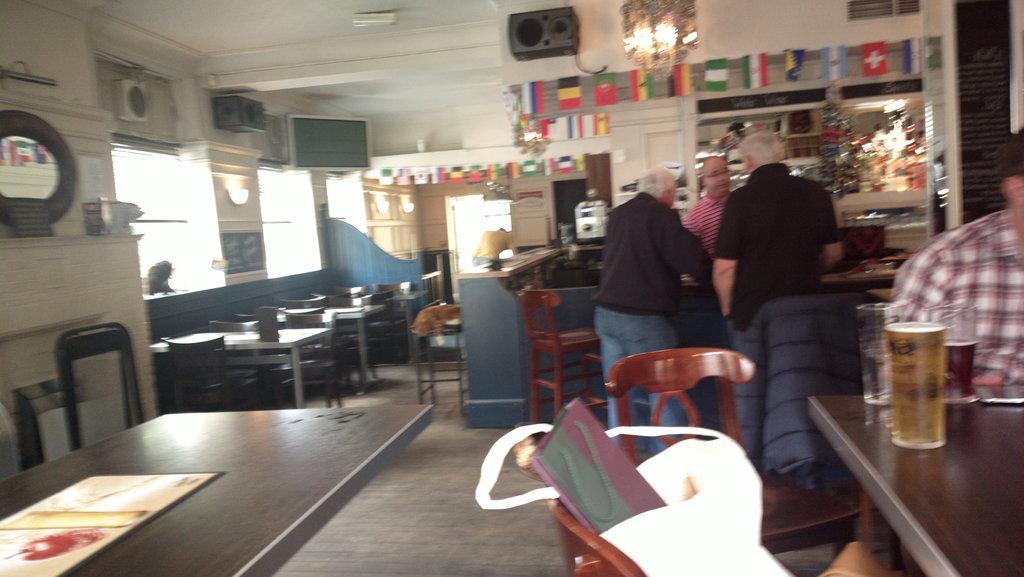In one or two sentences, can you explain what this image depicts? On the right we can see one man sitting and front there is a table. On the left we can see another table. In the center we can see three persons were standing and few empty chairs. In the background there is a monitor,speaker,mirror,window,tables,chairs,door,lights and flags. 